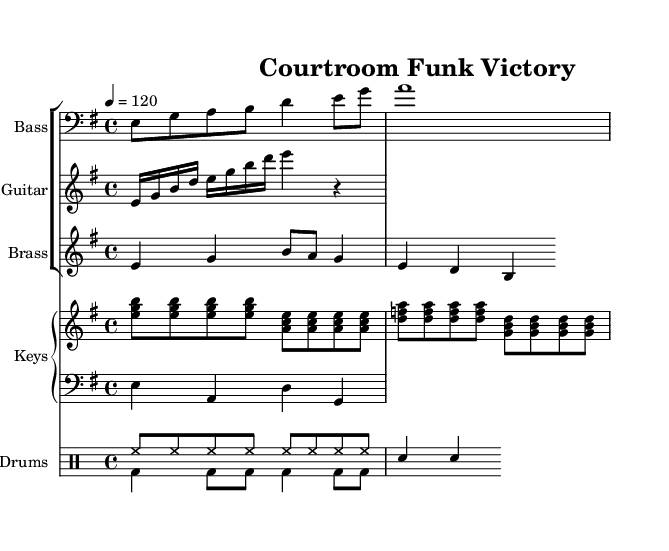What is the key signature of this music? The key signature indicated at the beginning of the piece is E minor, which contains one sharp (F#).
Answer: E minor What is the time signature of the music? The time signature is shown at the beginning of the sheet music, indicating a 4/4 meter, meaning there are four beats in each measure and a quarter note gets one beat.
Answer: 4/4 What is the tempo marking for this piece? The tempo marking is given in the score, which specifies a tempo of 120 beats per minute, indicating a moderately fast pace.
Answer: 120 How many measures are in the bass line? By counting the individual measures represented in the bass line, there are a total of four measures.
Answer: 4 What is the highest note in the guitar riff? Looking at the guitar staff, the highest note played is B, which is located on the second line of the treble staff.
Answer: B How many instruments are featured in this piece? The score shows multiple staves for different instruments: bass, guitar, brass, piano (with both upper and lower parts), and drums, totaling five distinct instruments.
Answer: 5 What is the rhythmic pattern of the drums in the first eight counts? The rhythmic pattern shown in the drum section consists of eight hi-hat hits followed by a snare. This creates a consistent upbeat feel typical in funk music.
Answer: Eight hi-hat hits followed by a snare 